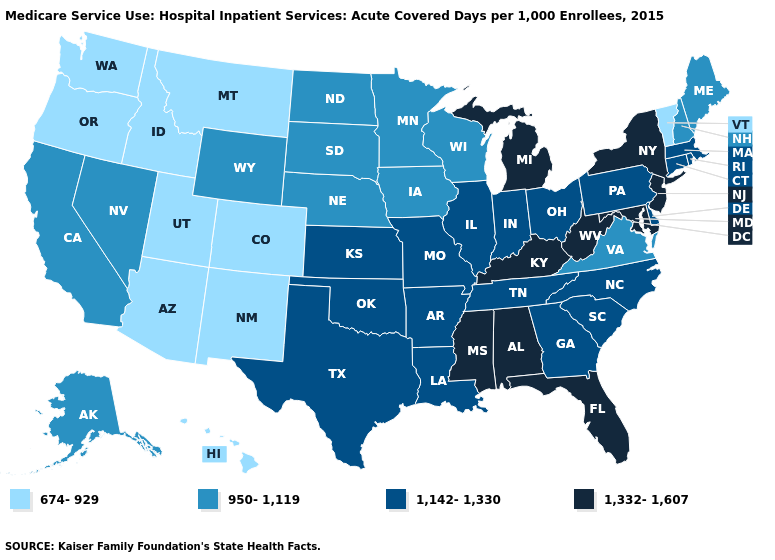What is the value of Oregon?
Keep it brief. 674-929. What is the value of Indiana?
Keep it brief. 1,142-1,330. Which states have the highest value in the USA?
Write a very short answer. Alabama, Florida, Kentucky, Maryland, Michigan, Mississippi, New Jersey, New York, West Virginia. Does Kentucky have the highest value in the USA?
Short answer required. Yes. Does Massachusetts have the same value as Florida?
Quick response, please. No. What is the highest value in the USA?
Concise answer only. 1,332-1,607. Name the states that have a value in the range 674-929?
Answer briefly. Arizona, Colorado, Hawaii, Idaho, Montana, New Mexico, Oregon, Utah, Vermont, Washington. Among the states that border Illinois , which have the lowest value?
Write a very short answer. Iowa, Wisconsin. Does Idaho have a higher value than Maryland?
Short answer required. No. What is the highest value in states that border Mississippi?
Quick response, please. 1,332-1,607. What is the lowest value in the USA?
Give a very brief answer. 674-929. Which states have the highest value in the USA?
Answer briefly. Alabama, Florida, Kentucky, Maryland, Michigan, Mississippi, New Jersey, New York, West Virginia. Name the states that have a value in the range 1,142-1,330?
Write a very short answer. Arkansas, Connecticut, Delaware, Georgia, Illinois, Indiana, Kansas, Louisiana, Massachusetts, Missouri, North Carolina, Ohio, Oklahoma, Pennsylvania, Rhode Island, South Carolina, Tennessee, Texas. Does Vermont have the lowest value in the USA?
Be succinct. Yes. What is the lowest value in the USA?
Quick response, please. 674-929. 